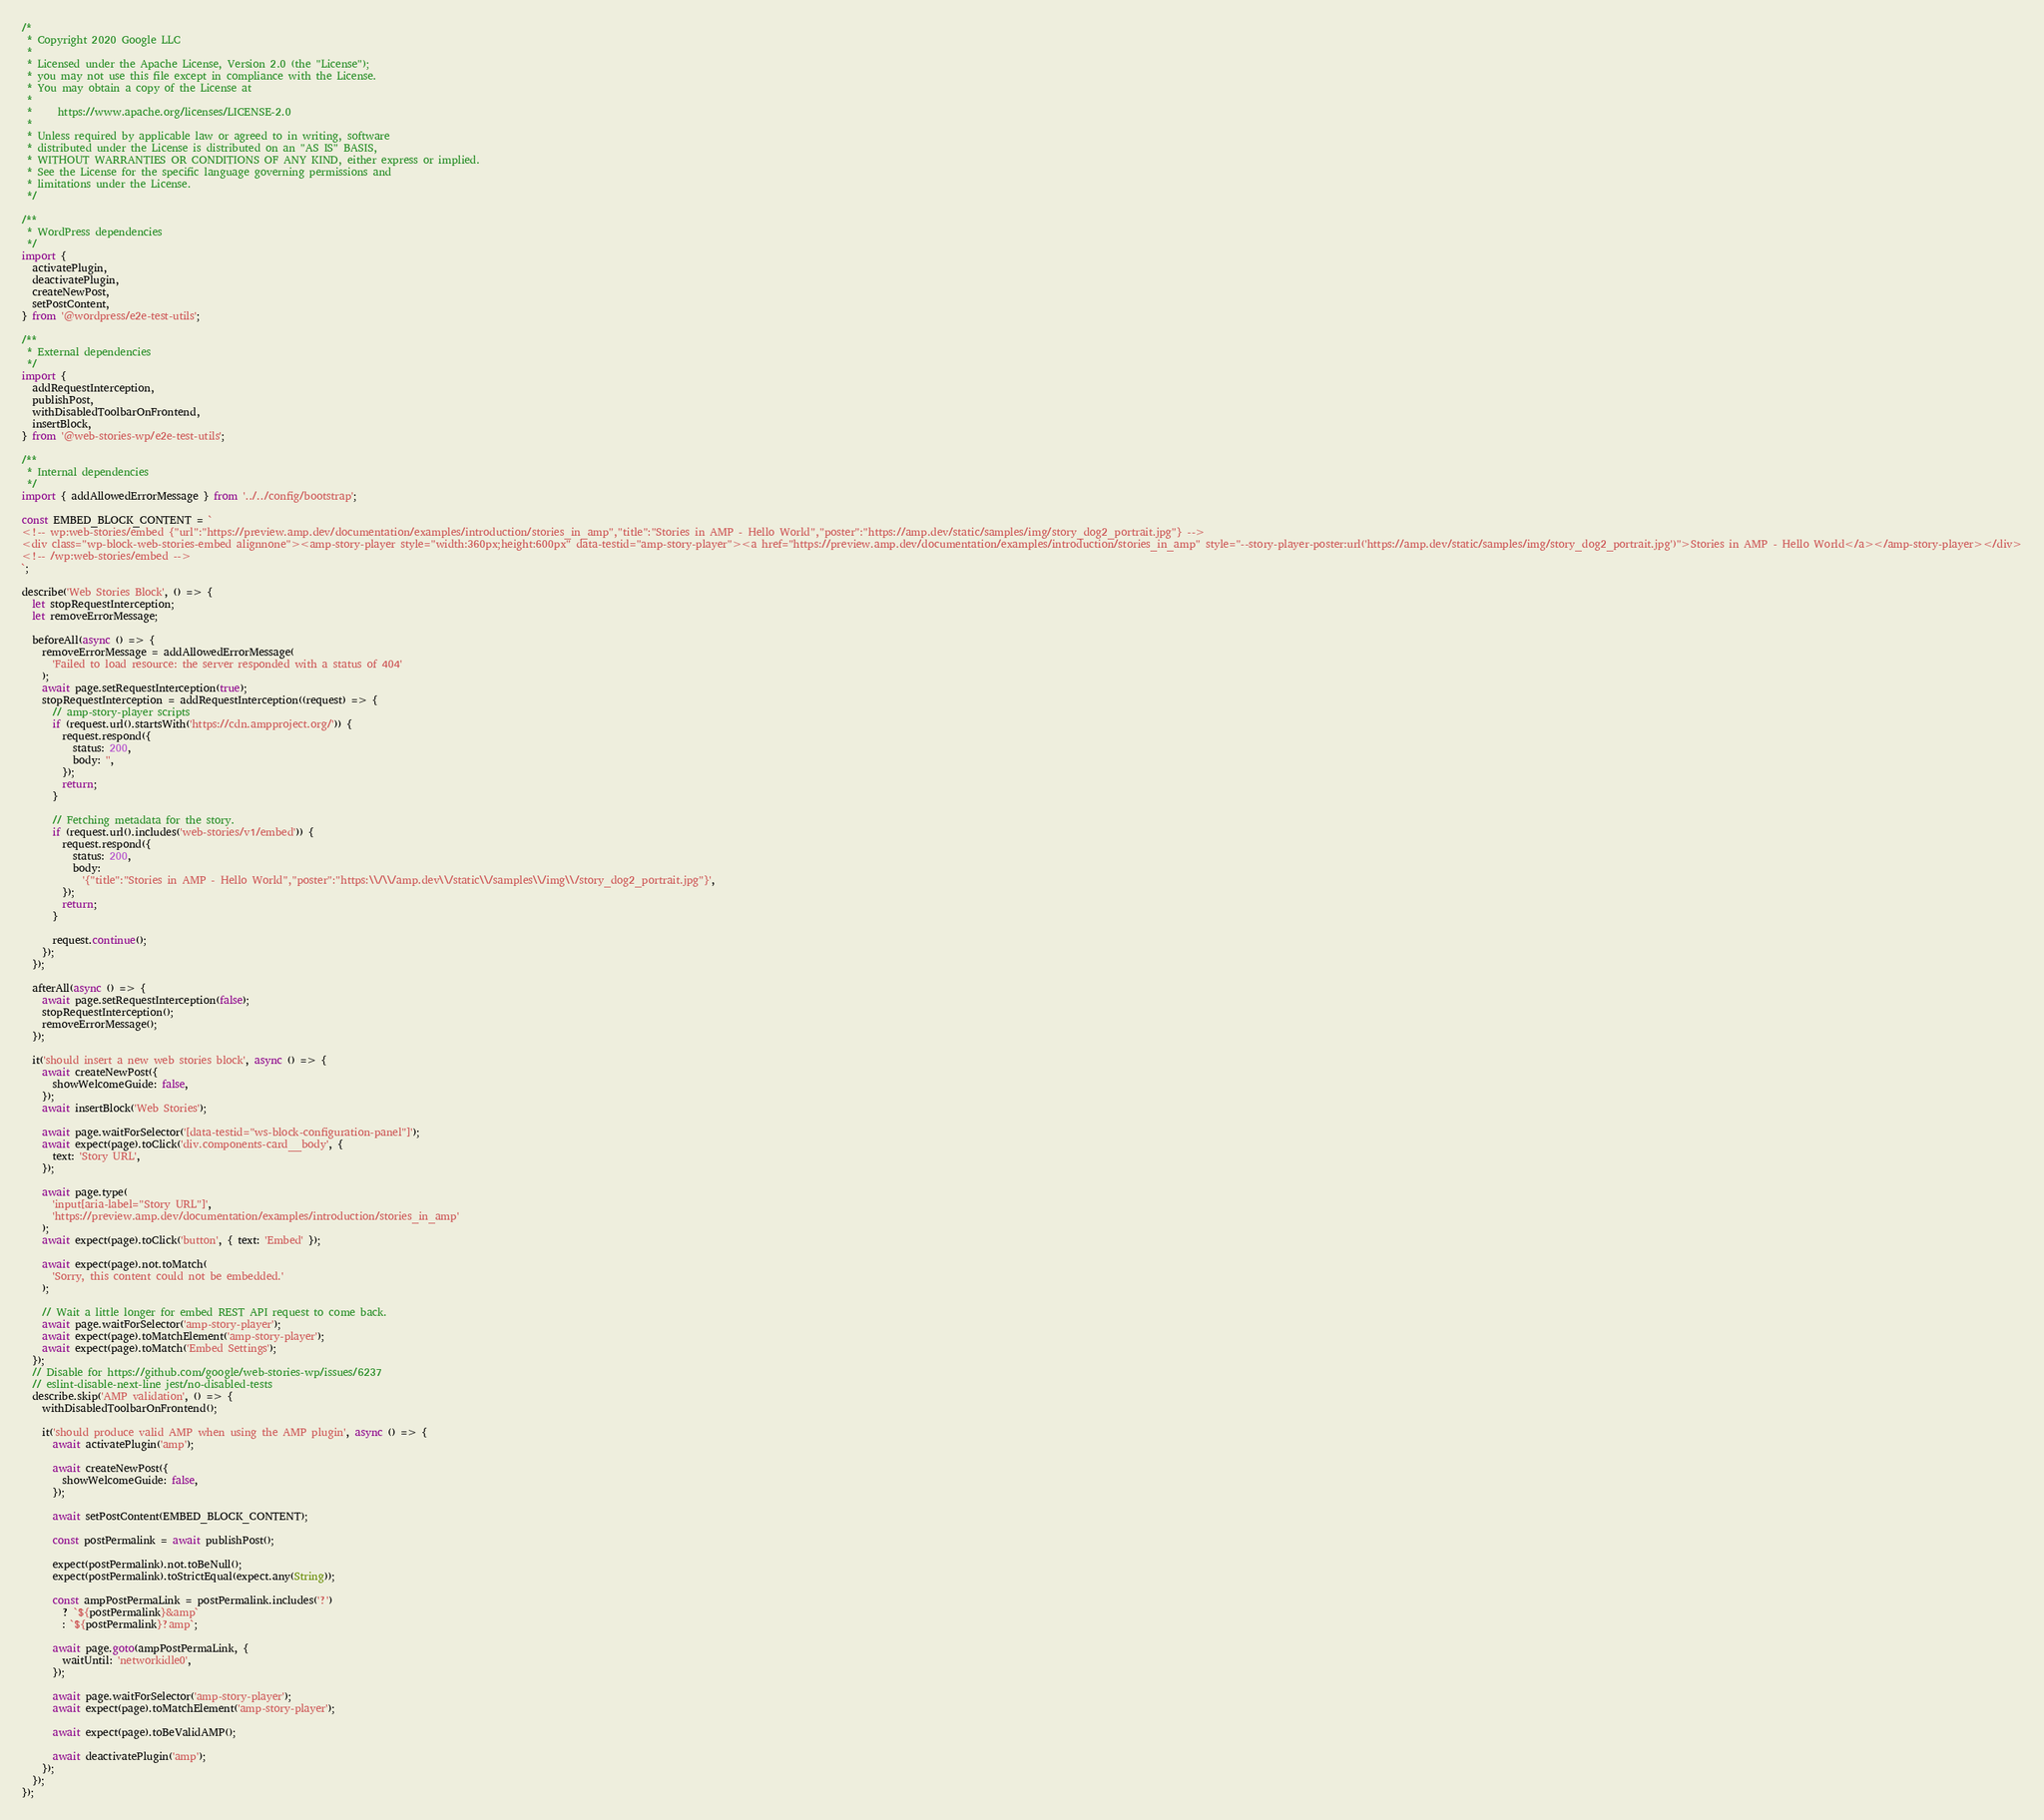<code> <loc_0><loc_0><loc_500><loc_500><_JavaScript_>/*
 * Copyright 2020 Google LLC
 *
 * Licensed under the Apache License, Version 2.0 (the "License");
 * you may not use this file except in compliance with the License.
 * You may obtain a copy of the License at
 *
 *     https://www.apache.org/licenses/LICENSE-2.0
 *
 * Unless required by applicable law or agreed to in writing, software
 * distributed under the License is distributed on an "AS IS" BASIS,
 * WITHOUT WARRANTIES OR CONDITIONS OF ANY KIND, either express or implied.
 * See the License for the specific language governing permissions and
 * limitations under the License.
 */

/**
 * WordPress dependencies
 */
import {
  activatePlugin,
  deactivatePlugin,
  createNewPost,
  setPostContent,
} from '@wordpress/e2e-test-utils';

/**
 * External dependencies
 */
import {
  addRequestInterception,
  publishPost,
  withDisabledToolbarOnFrontend,
  insertBlock,
} from '@web-stories-wp/e2e-test-utils';

/**
 * Internal dependencies
 */
import { addAllowedErrorMessage } from '../../config/bootstrap';

const EMBED_BLOCK_CONTENT = `
<!-- wp:web-stories/embed {"url":"https://preview.amp.dev/documentation/examples/introduction/stories_in_amp","title":"Stories in AMP - Hello World","poster":"https://amp.dev/static/samples/img/story_dog2_portrait.jpg"} -->
<div class="wp-block-web-stories-embed alignnone"><amp-story-player style="width:360px;height:600px" data-testid="amp-story-player"><a href="https://preview.amp.dev/documentation/examples/introduction/stories_in_amp" style="--story-player-poster:url('https://amp.dev/static/samples/img/story_dog2_portrait.jpg')">Stories in AMP - Hello World</a></amp-story-player></div>
<!-- /wp:web-stories/embed -->
`;

describe('Web Stories Block', () => {
  let stopRequestInterception;
  let removeErrorMessage;

  beforeAll(async () => {
    removeErrorMessage = addAllowedErrorMessage(
      'Failed to load resource: the server responded with a status of 404'
    );
    await page.setRequestInterception(true);
    stopRequestInterception = addRequestInterception((request) => {
      // amp-story-player scripts
      if (request.url().startsWith('https://cdn.ampproject.org/')) {
        request.respond({
          status: 200,
          body: '',
        });
        return;
      }

      // Fetching metadata for the story.
      if (request.url().includes('web-stories/v1/embed')) {
        request.respond({
          status: 200,
          body:
            '{"title":"Stories in AMP - Hello World","poster":"https:\\/\\/amp.dev\\/static\\/samples\\/img\\/story_dog2_portrait.jpg"}',
        });
        return;
      }

      request.continue();
    });
  });

  afterAll(async () => {
    await page.setRequestInterception(false);
    stopRequestInterception();
    removeErrorMessage();
  });

  it('should insert a new web stories block', async () => {
    await createNewPost({
      showWelcomeGuide: false,
    });
    await insertBlock('Web Stories');

    await page.waitForSelector('[data-testid="ws-block-configuration-panel"]');
    await expect(page).toClick('div.components-card__body', {
      text: 'Story URL',
    });

    await page.type(
      'input[aria-label="Story URL"]',
      'https://preview.amp.dev/documentation/examples/introduction/stories_in_amp'
    );
    await expect(page).toClick('button', { text: 'Embed' });

    await expect(page).not.toMatch(
      'Sorry, this content could not be embedded.'
    );

    // Wait a little longer for embed REST API request to come back.
    await page.waitForSelector('amp-story-player');
    await expect(page).toMatchElement('amp-story-player');
    await expect(page).toMatch('Embed Settings');
  });
  // Disable for https://github.com/google/web-stories-wp/issues/6237
  // eslint-disable-next-line jest/no-disabled-tests
  describe.skip('AMP validation', () => {
    withDisabledToolbarOnFrontend();

    it('should produce valid AMP when using the AMP plugin', async () => {
      await activatePlugin('amp');

      await createNewPost({
        showWelcomeGuide: false,
      });

      await setPostContent(EMBED_BLOCK_CONTENT);

      const postPermalink = await publishPost();

      expect(postPermalink).not.toBeNull();
      expect(postPermalink).toStrictEqual(expect.any(String));

      const ampPostPermaLink = postPermalink.includes('?')
        ? `${postPermalink}&amp`
        : `${postPermalink}?amp`;

      await page.goto(ampPostPermaLink, {
        waitUntil: 'networkidle0',
      });

      await page.waitForSelector('amp-story-player');
      await expect(page).toMatchElement('amp-story-player');

      await expect(page).toBeValidAMP();

      await deactivatePlugin('amp');
    });
  });
});
</code> 